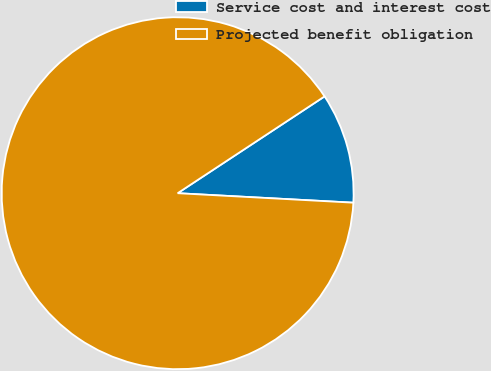Convert chart to OTSL. <chart><loc_0><loc_0><loc_500><loc_500><pie_chart><fcel>Service cost and interest cost<fcel>Projected benefit obligation<nl><fcel>10.13%<fcel>89.87%<nl></chart> 